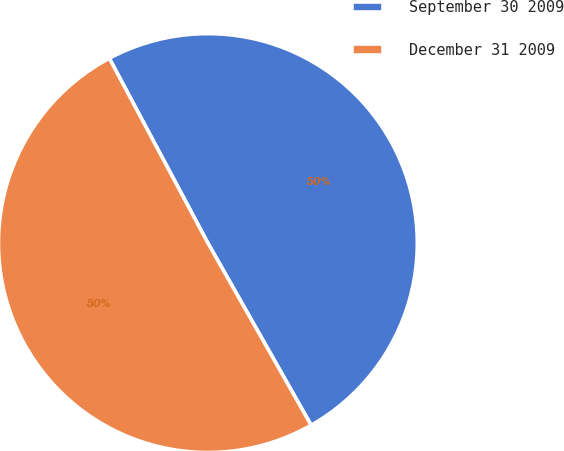Convert chart. <chart><loc_0><loc_0><loc_500><loc_500><pie_chart><fcel>September 30 2009<fcel>December 31 2009<nl><fcel>49.59%<fcel>50.41%<nl></chart> 